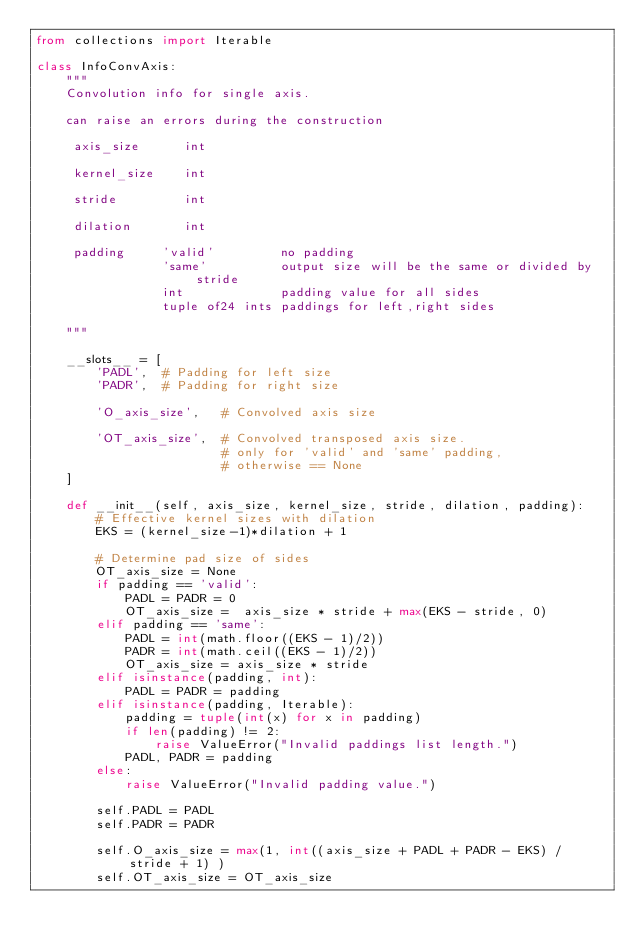<code> <loc_0><loc_0><loc_500><loc_500><_Python_>from collections import Iterable

class InfoConvAxis:
    """
    Convolution info for single axis. 
    
    can raise an errors during the construction
    
     axis_size      int
     
     kernel_size    int
     
     stride         int
     
     dilation       int
     
     padding     'valid'         no padding
                 'same'          output size will be the same or divided by stride
                 int             padding value for all sides
                 tuple of24 ints paddings for left,right sides

    """
    
    __slots__ = [
        'PADL',  # Padding for left size
        'PADR',  # Padding for right size
        
        'O_axis_size',   # Convolved axis size
        
        'OT_axis_size',  # Convolved transposed axis size.
                         # only for 'valid' and 'same' padding,
                         # otherwise == None
    ]
    
    def __init__(self, axis_size, kernel_size, stride, dilation, padding):        
        # Effective kernel sizes with dilation
        EKS = (kernel_size-1)*dilation + 1

        # Determine pad size of sides
        OT_axis_size = None
        if padding == 'valid':
            PADL = PADR = 0
            OT_axis_size =  axis_size * stride + max(EKS - stride, 0)
        elif padding == 'same':
            PADL = int(math.floor((EKS - 1)/2))
            PADR = int(math.ceil((EKS - 1)/2))
            OT_axis_size = axis_size * stride      
        elif isinstance(padding, int):
            PADL = PADR = padding
        elif isinstance(padding, Iterable):
            padding = tuple(int(x) for x in padding)
            if len(padding) != 2:
                raise ValueError("Invalid paddings list length.")
            PADL, PADR = padding
        else:
            raise ValueError("Invalid padding value.")
        
        self.PADL = PADL
        self.PADR = PADR
            
        self.O_axis_size = max(1, int((axis_size + PADL + PADR - EKS) / stride + 1) )
        self.OT_axis_size = OT_axis_size
                                    </code> 